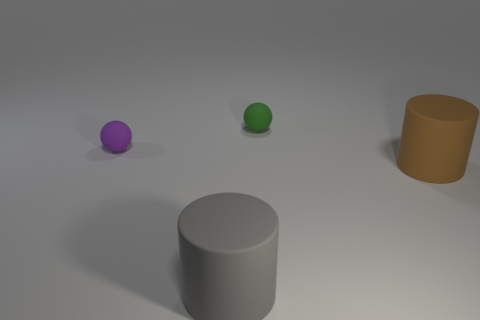Add 4 large brown things. How many objects exist? 8 Subtract all purple balls. How many balls are left? 1 Subtract all gray cylinders. How many purple spheres are left? 1 Subtract all big blue metallic objects. Subtract all large brown things. How many objects are left? 3 Add 3 tiny purple objects. How many tiny purple objects are left? 4 Add 1 small green things. How many small green things exist? 2 Subtract 0 green cubes. How many objects are left? 4 Subtract 2 cylinders. How many cylinders are left? 0 Subtract all gray cylinders. Subtract all cyan blocks. How many cylinders are left? 1 